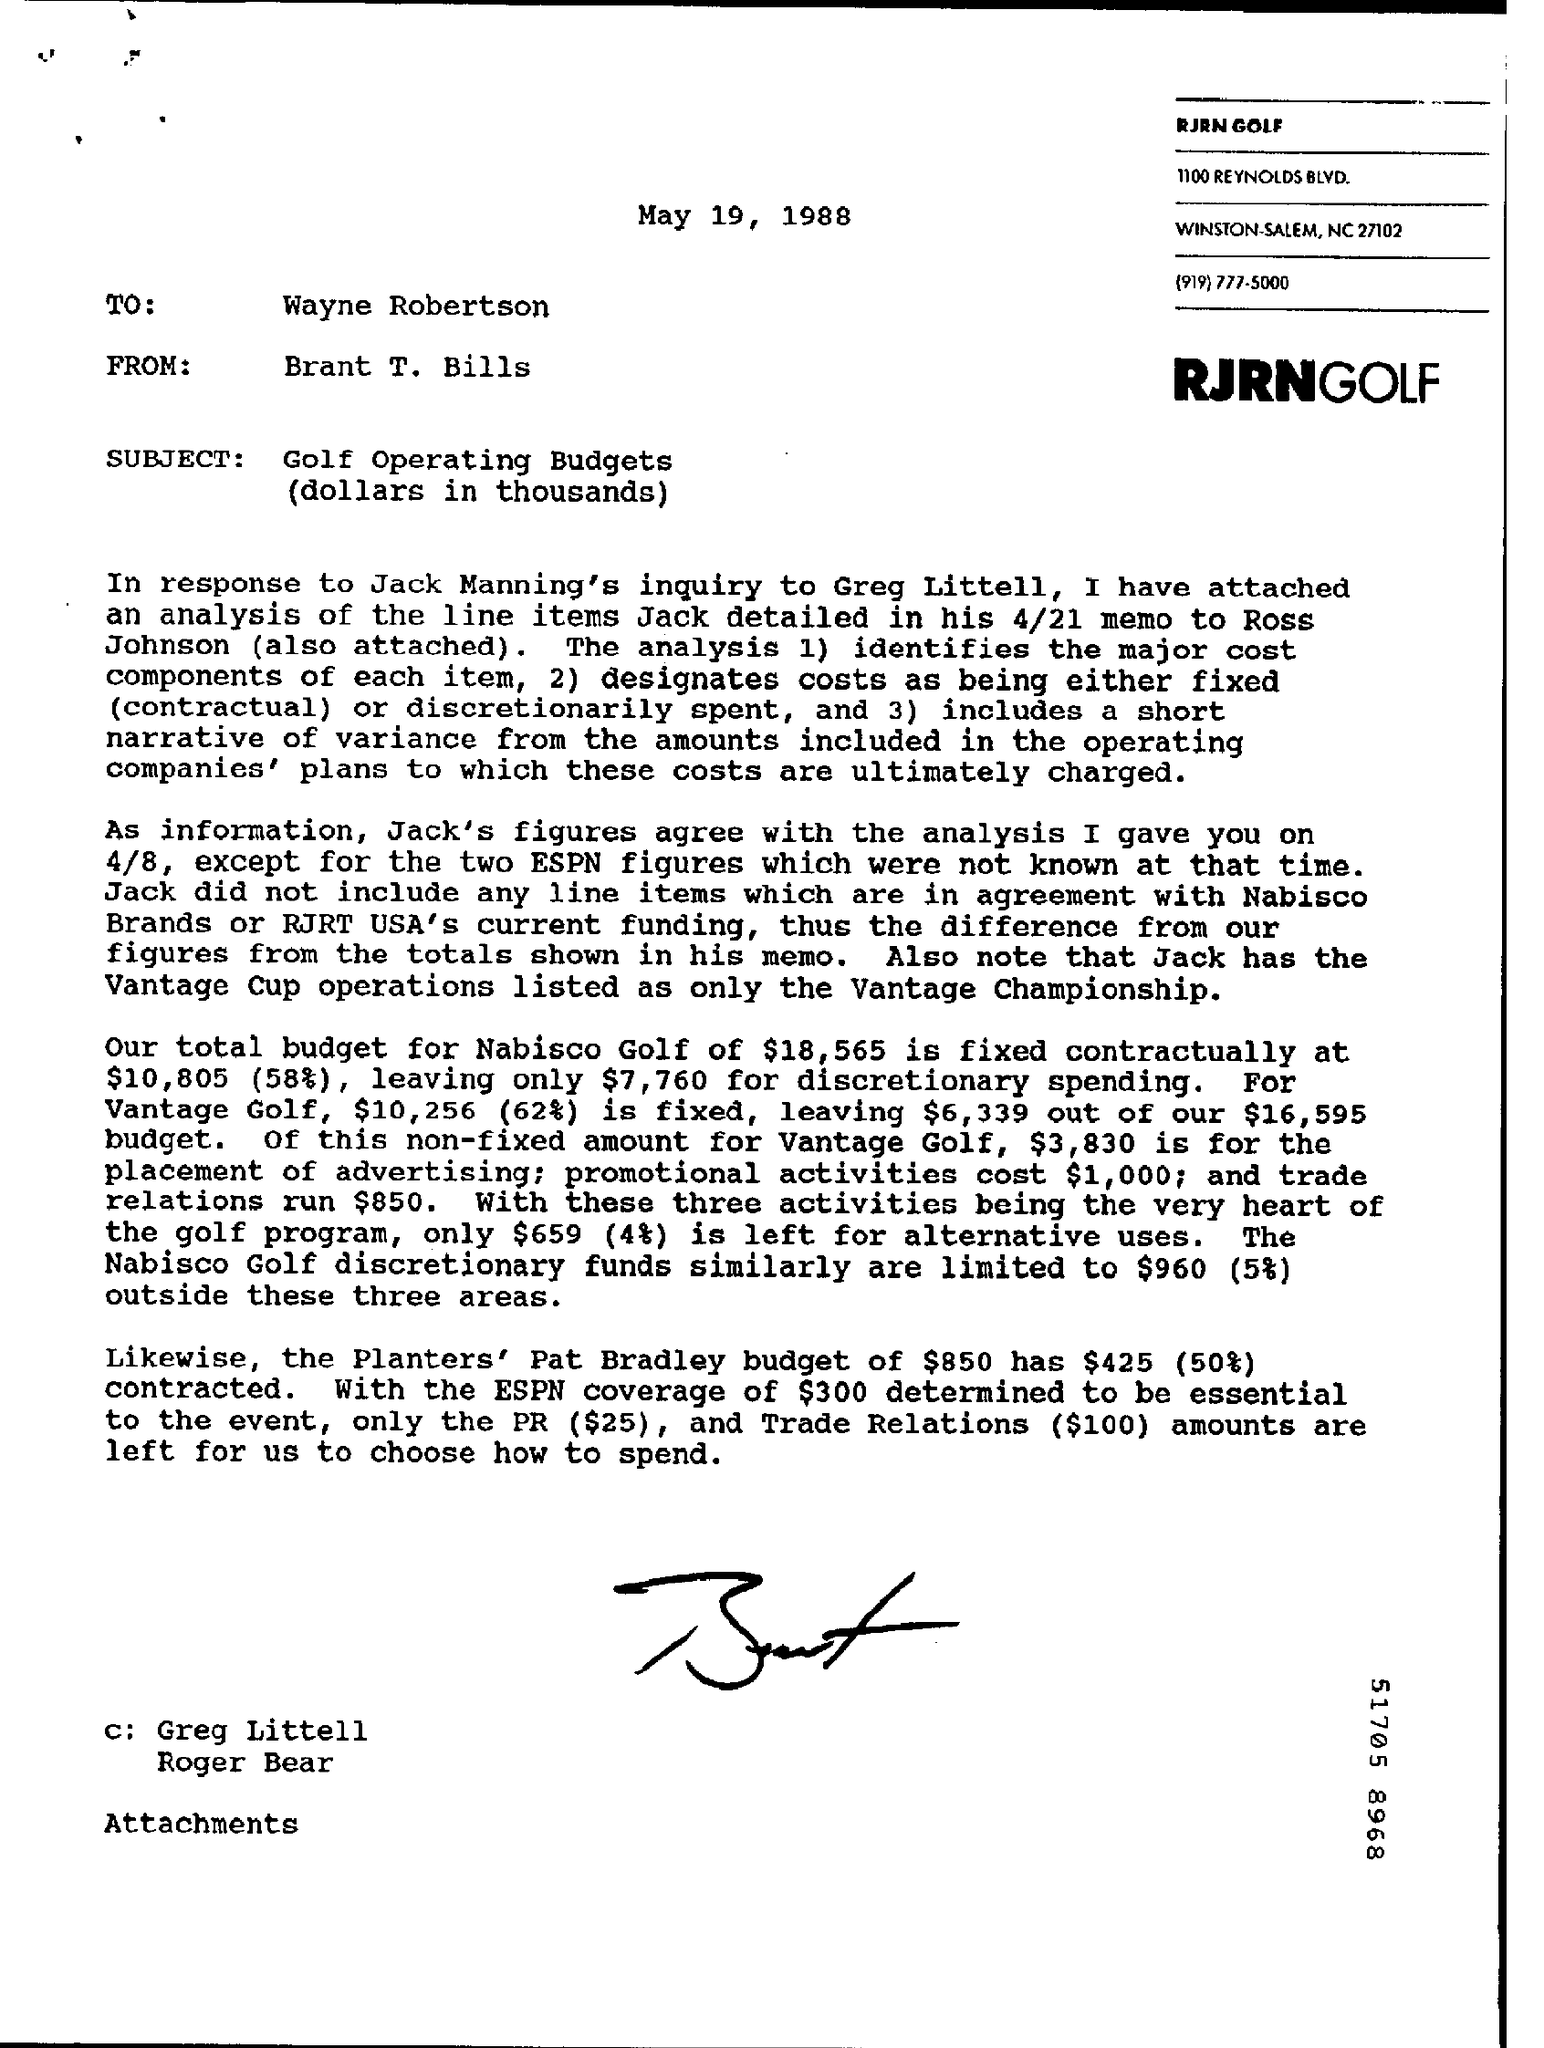Point out several critical features in this image. The date is May 19, 1988. The letter is from Brant T. Bills. The total budget for Nabisco Golf is $18,565. The letter is addressed to Wayne Robertson. 